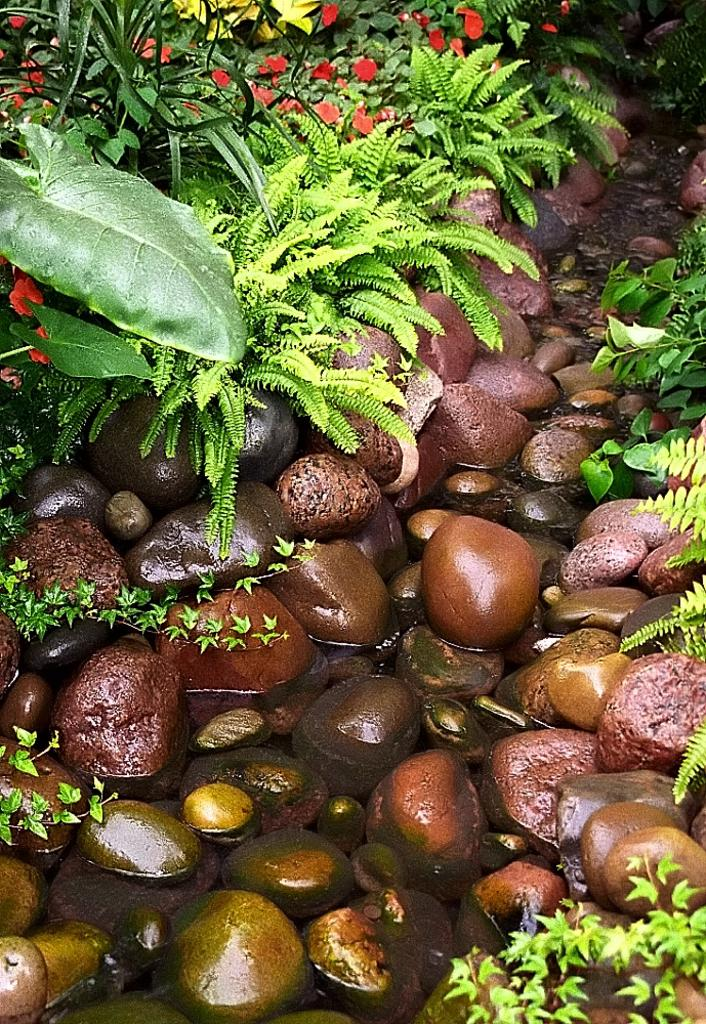What is in the water in the image? There are stones in the water in the image. What other elements can be seen in the image? There are plants and flowers in the image. What is the color of the flowers? The flowers are red in color. Where can you find a cushion in the image? There is no cushion present in the image. What news is being reported in the image? There is no news being reported in the image; it features stones, plants, and flowers. 